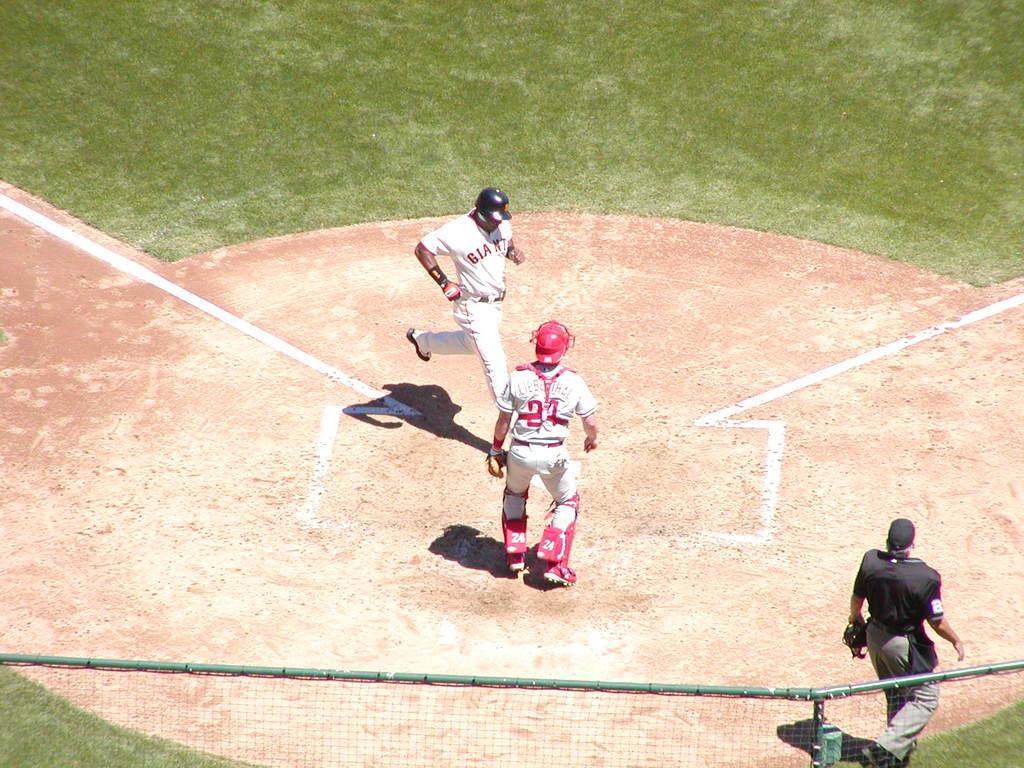Could you give a brief overview of what you see in this image? In this image I can see ground and on it I can see grass, shadows, white lines and I can see few people are standing. I can see two of them are wearing white dress and one is wearing black. I can also see all of them are wearing helmets, gloves and here I can see something is written on their dresses. I can also see fencing over here. 